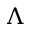Convert formula to latex. <formula><loc_0><loc_0><loc_500><loc_500>\Lambda</formula> 